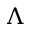Convert formula to latex. <formula><loc_0><loc_0><loc_500><loc_500>\Lambda</formula> 